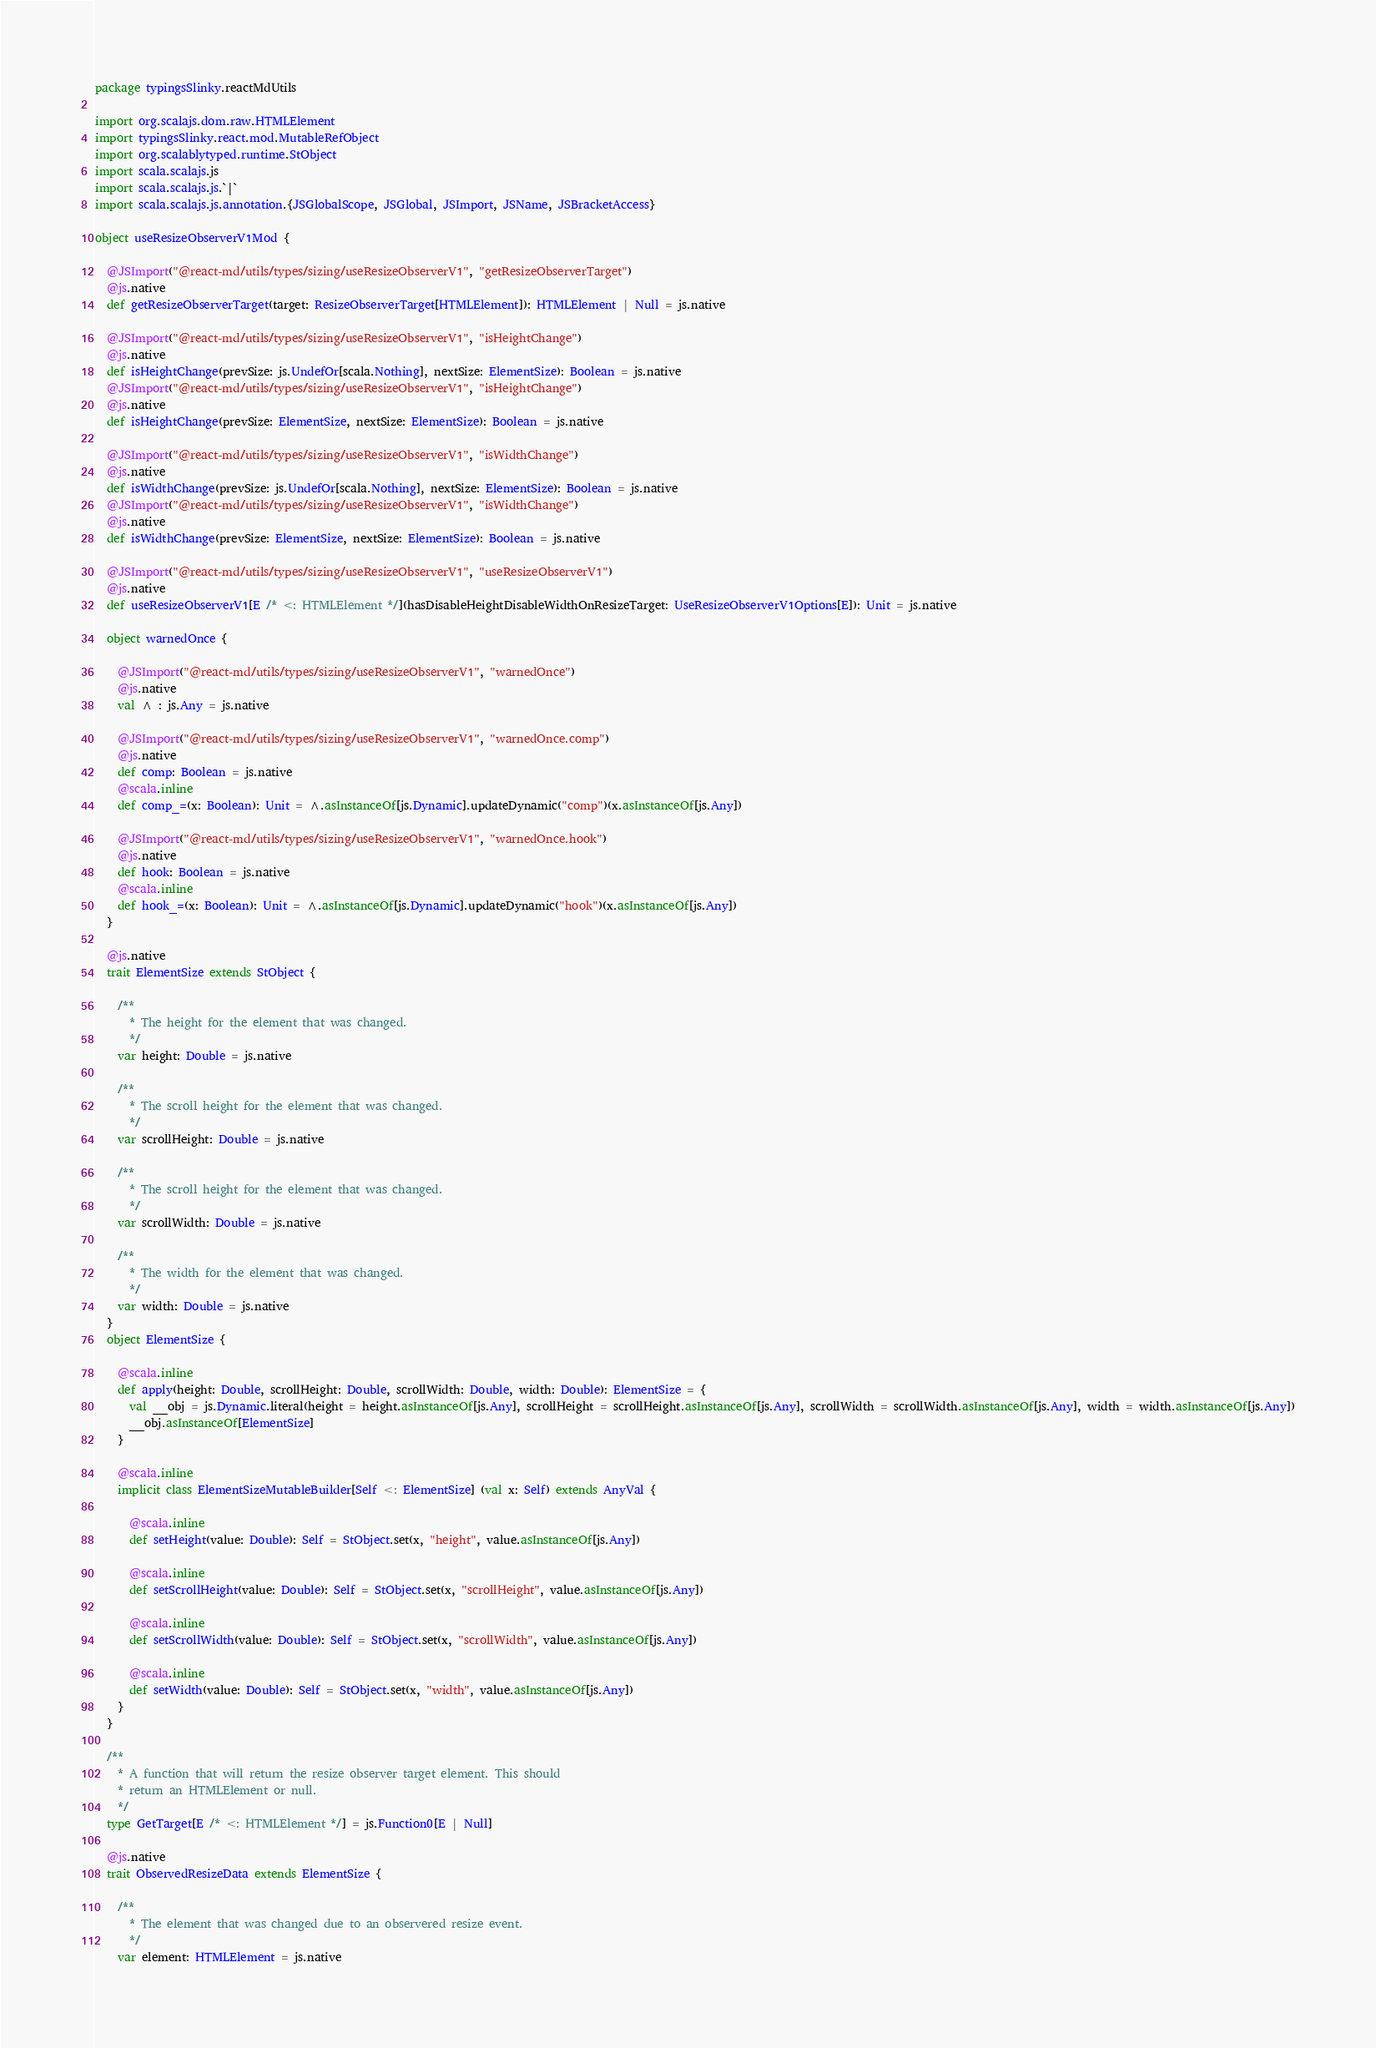Convert code to text. <code><loc_0><loc_0><loc_500><loc_500><_Scala_>package typingsSlinky.reactMdUtils

import org.scalajs.dom.raw.HTMLElement
import typingsSlinky.react.mod.MutableRefObject
import org.scalablytyped.runtime.StObject
import scala.scalajs.js
import scala.scalajs.js.`|`
import scala.scalajs.js.annotation.{JSGlobalScope, JSGlobal, JSImport, JSName, JSBracketAccess}

object useResizeObserverV1Mod {
  
  @JSImport("@react-md/utils/types/sizing/useResizeObserverV1", "getResizeObserverTarget")
  @js.native
  def getResizeObserverTarget(target: ResizeObserverTarget[HTMLElement]): HTMLElement | Null = js.native
  
  @JSImport("@react-md/utils/types/sizing/useResizeObserverV1", "isHeightChange")
  @js.native
  def isHeightChange(prevSize: js.UndefOr[scala.Nothing], nextSize: ElementSize): Boolean = js.native
  @JSImport("@react-md/utils/types/sizing/useResizeObserverV1", "isHeightChange")
  @js.native
  def isHeightChange(prevSize: ElementSize, nextSize: ElementSize): Boolean = js.native
  
  @JSImport("@react-md/utils/types/sizing/useResizeObserverV1", "isWidthChange")
  @js.native
  def isWidthChange(prevSize: js.UndefOr[scala.Nothing], nextSize: ElementSize): Boolean = js.native
  @JSImport("@react-md/utils/types/sizing/useResizeObserverV1", "isWidthChange")
  @js.native
  def isWidthChange(prevSize: ElementSize, nextSize: ElementSize): Boolean = js.native
  
  @JSImport("@react-md/utils/types/sizing/useResizeObserverV1", "useResizeObserverV1")
  @js.native
  def useResizeObserverV1[E /* <: HTMLElement */](hasDisableHeightDisableWidthOnResizeTarget: UseResizeObserverV1Options[E]): Unit = js.native
  
  object warnedOnce {
    
    @JSImport("@react-md/utils/types/sizing/useResizeObserverV1", "warnedOnce")
    @js.native
    val ^ : js.Any = js.native
    
    @JSImport("@react-md/utils/types/sizing/useResizeObserverV1", "warnedOnce.comp")
    @js.native
    def comp: Boolean = js.native
    @scala.inline
    def comp_=(x: Boolean): Unit = ^.asInstanceOf[js.Dynamic].updateDynamic("comp")(x.asInstanceOf[js.Any])
    
    @JSImport("@react-md/utils/types/sizing/useResizeObserverV1", "warnedOnce.hook")
    @js.native
    def hook: Boolean = js.native
    @scala.inline
    def hook_=(x: Boolean): Unit = ^.asInstanceOf[js.Dynamic].updateDynamic("hook")(x.asInstanceOf[js.Any])
  }
  
  @js.native
  trait ElementSize extends StObject {
    
    /**
      * The height for the element that was changed.
      */
    var height: Double = js.native
    
    /**
      * The scroll height for the element that was changed.
      */
    var scrollHeight: Double = js.native
    
    /**
      * The scroll height for the element that was changed.
      */
    var scrollWidth: Double = js.native
    
    /**
      * The width for the element that was changed.
      */
    var width: Double = js.native
  }
  object ElementSize {
    
    @scala.inline
    def apply(height: Double, scrollHeight: Double, scrollWidth: Double, width: Double): ElementSize = {
      val __obj = js.Dynamic.literal(height = height.asInstanceOf[js.Any], scrollHeight = scrollHeight.asInstanceOf[js.Any], scrollWidth = scrollWidth.asInstanceOf[js.Any], width = width.asInstanceOf[js.Any])
      __obj.asInstanceOf[ElementSize]
    }
    
    @scala.inline
    implicit class ElementSizeMutableBuilder[Self <: ElementSize] (val x: Self) extends AnyVal {
      
      @scala.inline
      def setHeight(value: Double): Self = StObject.set(x, "height", value.asInstanceOf[js.Any])
      
      @scala.inline
      def setScrollHeight(value: Double): Self = StObject.set(x, "scrollHeight", value.asInstanceOf[js.Any])
      
      @scala.inline
      def setScrollWidth(value: Double): Self = StObject.set(x, "scrollWidth", value.asInstanceOf[js.Any])
      
      @scala.inline
      def setWidth(value: Double): Self = StObject.set(x, "width", value.asInstanceOf[js.Any])
    }
  }
  
  /**
    * A function that will return the resize observer target element. This should
    * return an HTMLElement or null.
    */
  type GetTarget[E /* <: HTMLElement */] = js.Function0[E | Null]
  
  @js.native
  trait ObservedResizeData extends ElementSize {
    
    /**
      * The element that was changed due to an observered resize event.
      */
    var element: HTMLElement = js.native</code> 